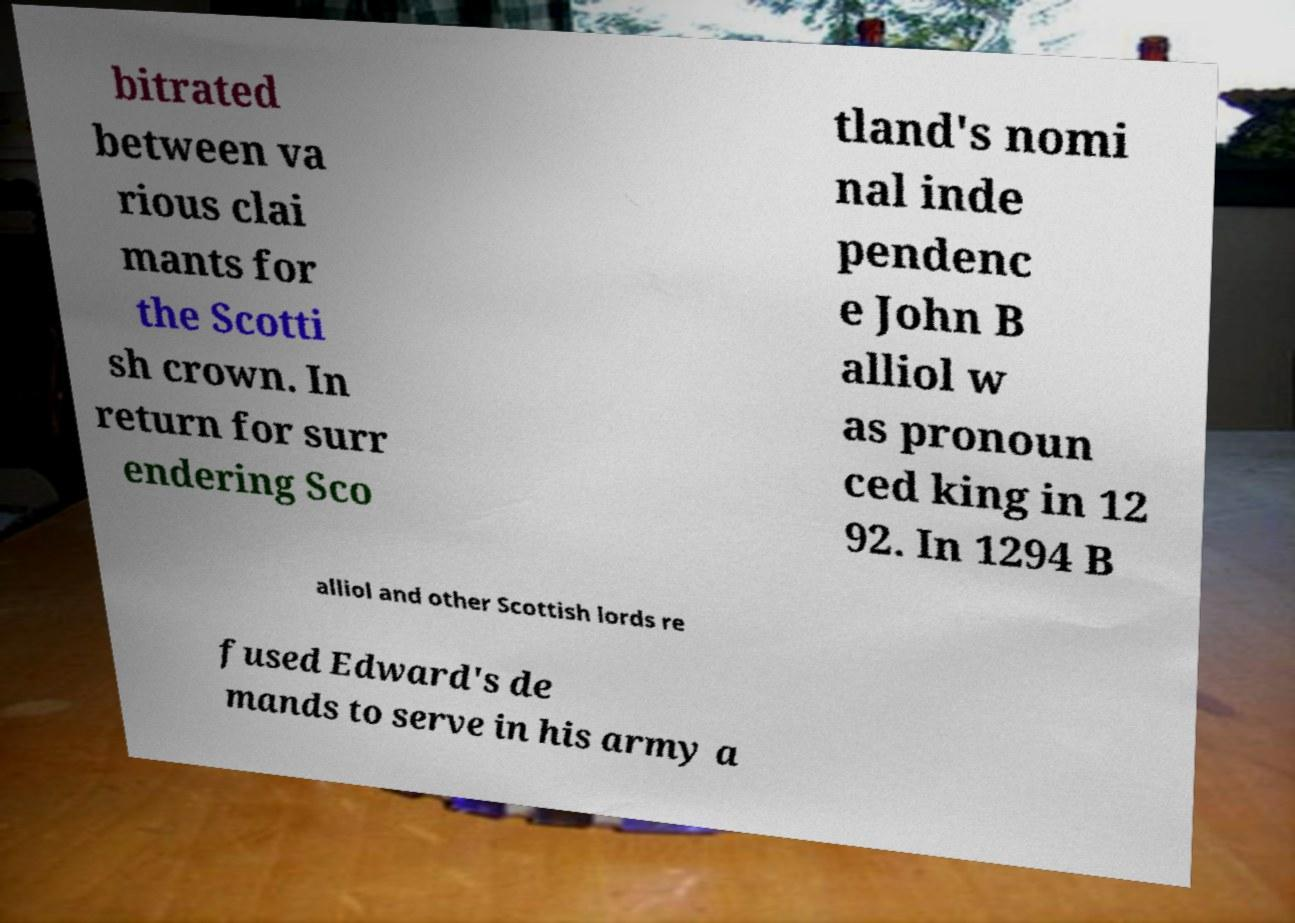Could you assist in decoding the text presented in this image and type it out clearly? bitrated between va rious clai mants for the Scotti sh crown. In return for surr endering Sco tland's nomi nal inde pendenc e John B alliol w as pronoun ced king in 12 92. In 1294 B alliol and other Scottish lords re fused Edward's de mands to serve in his army a 